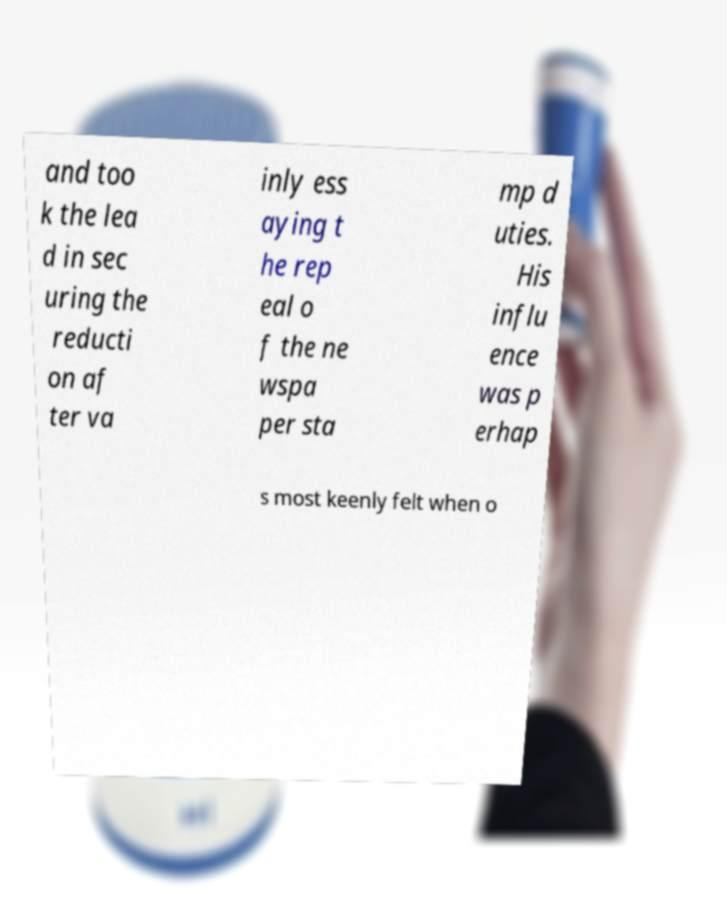Please identify and transcribe the text found in this image. and too k the lea d in sec uring the reducti on af ter va inly ess aying t he rep eal o f the ne wspa per sta mp d uties. His influ ence was p erhap s most keenly felt when o 